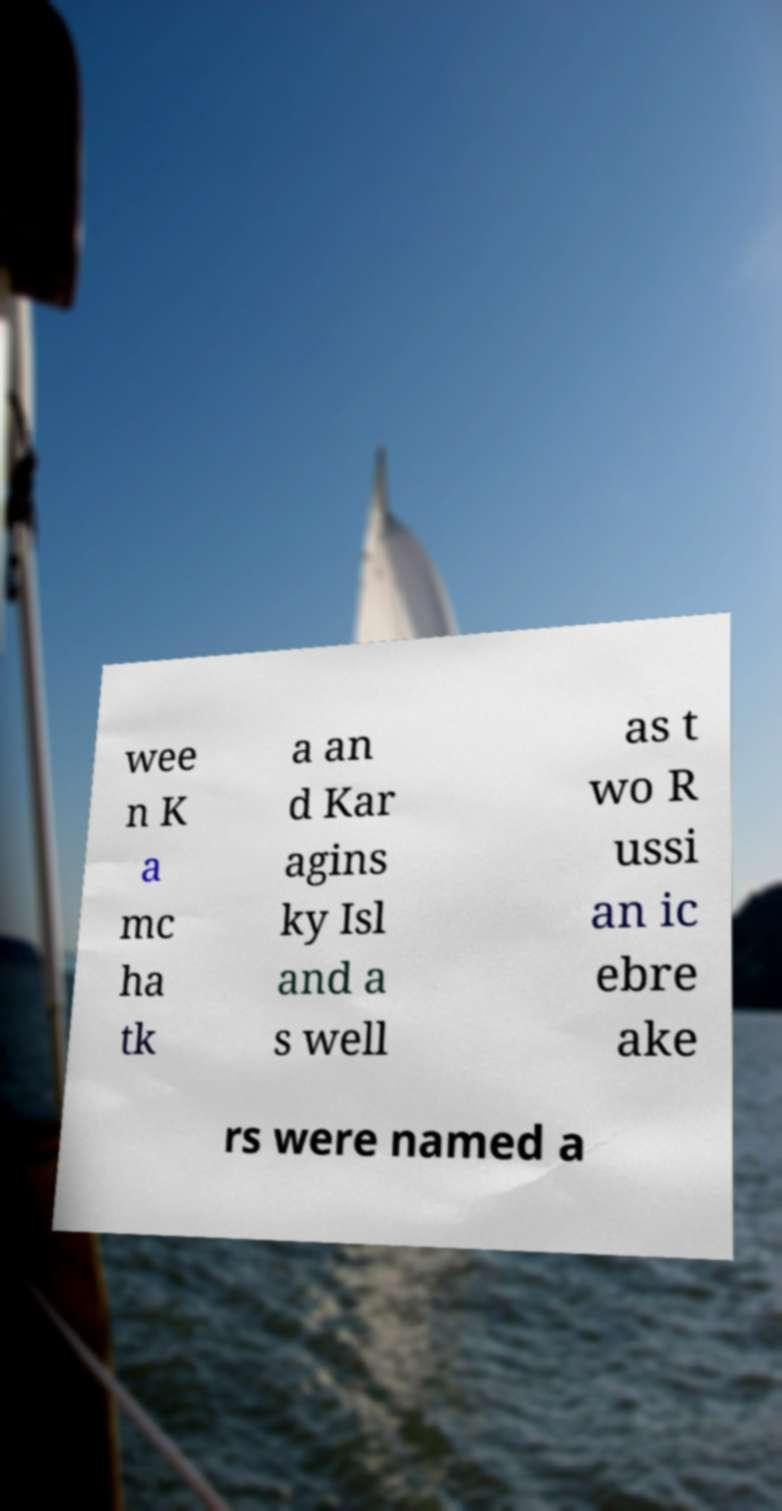For documentation purposes, I need the text within this image transcribed. Could you provide that? wee n K a mc ha tk a an d Kar agins ky Isl and a s well as t wo R ussi an ic ebre ake rs were named a 